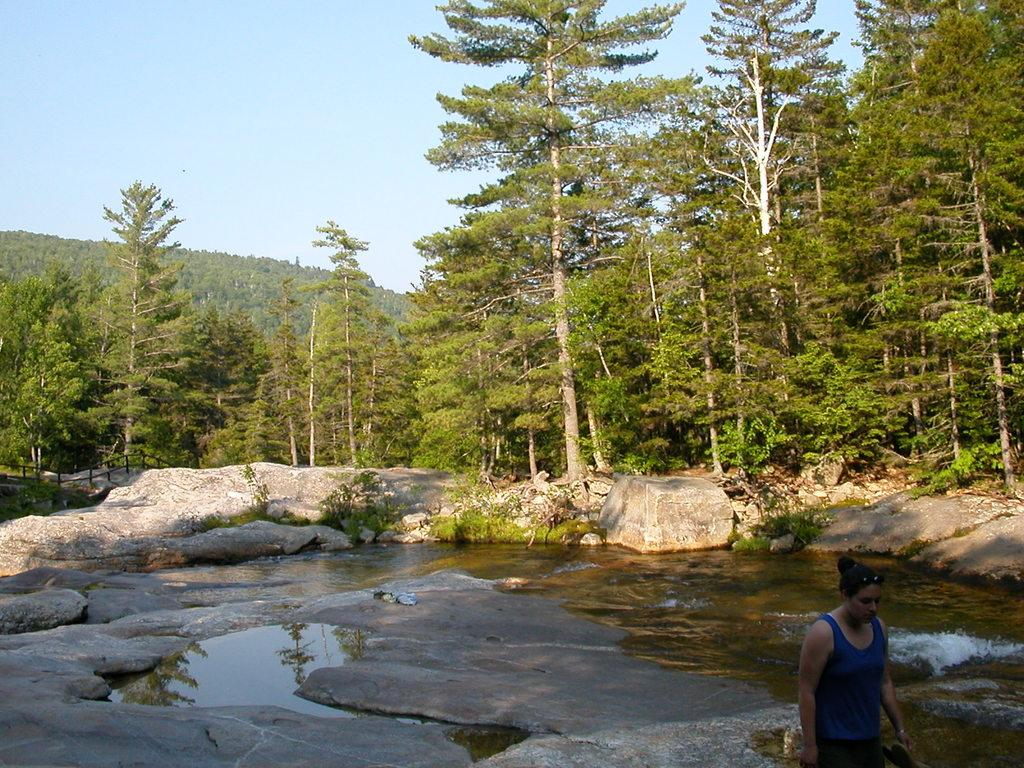What is covering the ground in the image? There is water on the ground in the image. What other natural elements can be seen in the image? There are rocks visible in the image. What can be seen in the distance in the image? There are trees visible in the background of the image. Who is present in the image? There is a woman standing in the image. What is the condition of the sky in the image? The sky is clear in the image. What type of flesh can be seen healing in the image? There is no flesh present in the image, and therefore no healing process can be observed. 